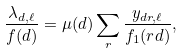<formula> <loc_0><loc_0><loc_500><loc_500>\frac { \lambda _ { d , \ell } } { f ( d ) } = \mu ( d ) \sum _ { r } \frac { y _ { d r , \ell } } { f _ { 1 } ( r d ) } ,</formula> 